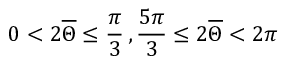Convert formula to latex. <formula><loc_0><loc_0><loc_500><loc_500>0 < 2 \overline { \Theta } \leq \frac { \pi } { 3 } \, , \frac { 5 \pi } { 3 } \leq 2 \overline { \Theta } < 2 \pi</formula> 